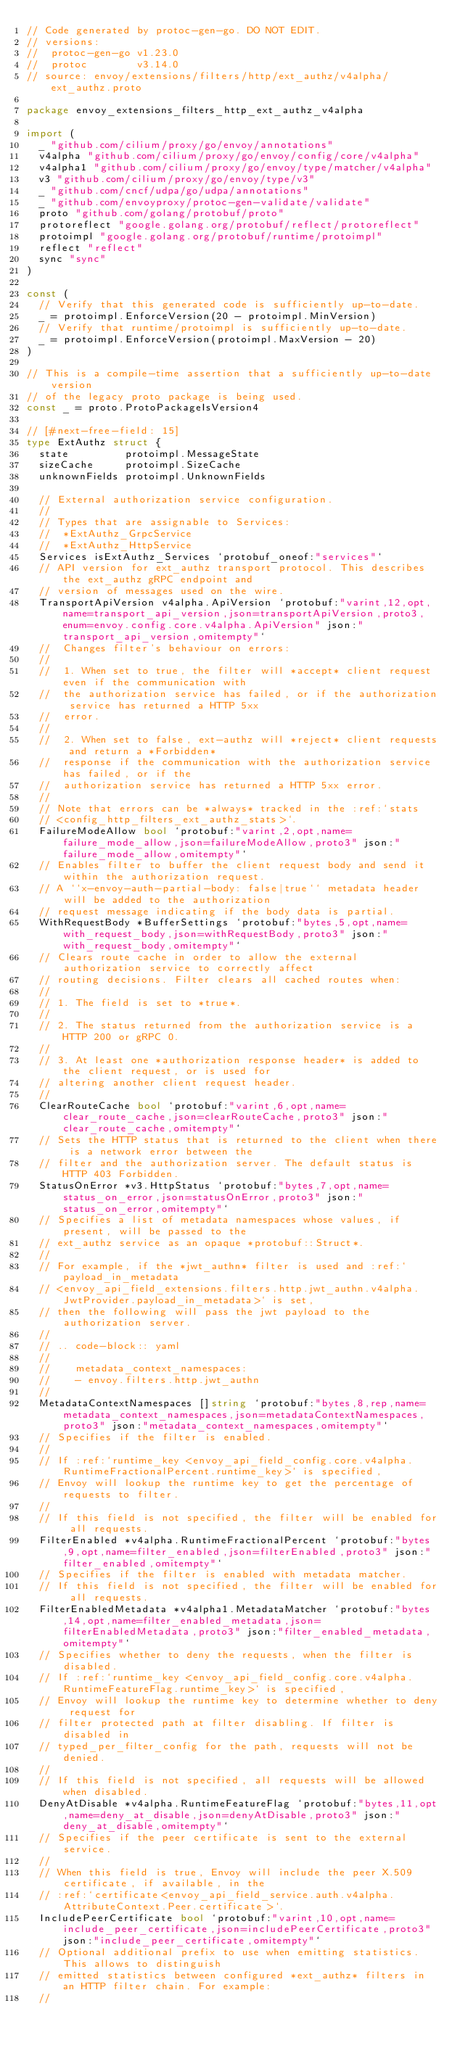<code> <loc_0><loc_0><loc_500><loc_500><_Go_>// Code generated by protoc-gen-go. DO NOT EDIT.
// versions:
// 	protoc-gen-go v1.23.0
// 	protoc        v3.14.0
// source: envoy/extensions/filters/http/ext_authz/v4alpha/ext_authz.proto

package envoy_extensions_filters_http_ext_authz_v4alpha

import (
	_ "github.com/cilium/proxy/go/envoy/annotations"
	v4alpha "github.com/cilium/proxy/go/envoy/config/core/v4alpha"
	v4alpha1 "github.com/cilium/proxy/go/envoy/type/matcher/v4alpha"
	v3 "github.com/cilium/proxy/go/envoy/type/v3"
	_ "github.com/cncf/udpa/go/udpa/annotations"
	_ "github.com/envoyproxy/protoc-gen-validate/validate"
	proto "github.com/golang/protobuf/proto"
	protoreflect "google.golang.org/protobuf/reflect/protoreflect"
	protoimpl "google.golang.org/protobuf/runtime/protoimpl"
	reflect "reflect"
	sync "sync"
)

const (
	// Verify that this generated code is sufficiently up-to-date.
	_ = protoimpl.EnforceVersion(20 - protoimpl.MinVersion)
	// Verify that runtime/protoimpl is sufficiently up-to-date.
	_ = protoimpl.EnforceVersion(protoimpl.MaxVersion - 20)
)

// This is a compile-time assertion that a sufficiently up-to-date version
// of the legacy proto package is being used.
const _ = proto.ProtoPackageIsVersion4

// [#next-free-field: 15]
type ExtAuthz struct {
	state         protoimpl.MessageState
	sizeCache     protoimpl.SizeCache
	unknownFields protoimpl.UnknownFields

	// External authorization service configuration.
	//
	// Types that are assignable to Services:
	//	*ExtAuthz_GrpcService
	//	*ExtAuthz_HttpService
	Services isExtAuthz_Services `protobuf_oneof:"services"`
	// API version for ext_authz transport protocol. This describes the ext_authz gRPC endpoint and
	// version of messages used on the wire.
	TransportApiVersion v4alpha.ApiVersion `protobuf:"varint,12,opt,name=transport_api_version,json=transportApiVersion,proto3,enum=envoy.config.core.v4alpha.ApiVersion" json:"transport_api_version,omitempty"`
	//  Changes filter's behaviour on errors:
	//
	//  1. When set to true, the filter will *accept* client request even if the communication with
	//  the authorization service has failed, or if the authorization service has returned a HTTP 5xx
	//  error.
	//
	//  2. When set to false, ext-authz will *reject* client requests and return a *Forbidden*
	//  response if the communication with the authorization service has failed, or if the
	//  authorization service has returned a HTTP 5xx error.
	//
	// Note that errors can be *always* tracked in the :ref:`stats
	// <config_http_filters_ext_authz_stats>`.
	FailureModeAllow bool `protobuf:"varint,2,opt,name=failure_mode_allow,json=failureModeAllow,proto3" json:"failure_mode_allow,omitempty"`
	// Enables filter to buffer the client request body and send it within the authorization request.
	// A ``x-envoy-auth-partial-body: false|true`` metadata header will be added to the authorization
	// request message indicating if the body data is partial.
	WithRequestBody *BufferSettings `protobuf:"bytes,5,opt,name=with_request_body,json=withRequestBody,proto3" json:"with_request_body,omitempty"`
	// Clears route cache in order to allow the external authorization service to correctly affect
	// routing decisions. Filter clears all cached routes when:
	//
	// 1. The field is set to *true*.
	//
	// 2. The status returned from the authorization service is a HTTP 200 or gRPC 0.
	//
	// 3. At least one *authorization response header* is added to the client request, or is used for
	// altering another client request header.
	//
	ClearRouteCache bool `protobuf:"varint,6,opt,name=clear_route_cache,json=clearRouteCache,proto3" json:"clear_route_cache,omitempty"`
	// Sets the HTTP status that is returned to the client when there is a network error between the
	// filter and the authorization server. The default status is HTTP 403 Forbidden.
	StatusOnError *v3.HttpStatus `protobuf:"bytes,7,opt,name=status_on_error,json=statusOnError,proto3" json:"status_on_error,omitempty"`
	// Specifies a list of metadata namespaces whose values, if present, will be passed to the
	// ext_authz service as an opaque *protobuf::Struct*.
	//
	// For example, if the *jwt_authn* filter is used and :ref:`payload_in_metadata
	// <envoy_api_field_extensions.filters.http.jwt_authn.v4alpha.JwtProvider.payload_in_metadata>` is set,
	// then the following will pass the jwt payload to the authorization server.
	//
	// .. code-block:: yaml
	//
	//    metadata_context_namespaces:
	//    - envoy.filters.http.jwt_authn
	//
	MetadataContextNamespaces []string `protobuf:"bytes,8,rep,name=metadata_context_namespaces,json=metadataContextNamespaces,proto3" json:"metadata_context_namespaces,omitempty"`
	// Specifies if the filter is enabled.
	//
	// If :ref:`runtime_key <envoy_api_field_config.core.v4alpha.RuntimeFractionalPercent.runtime_key>` is specified,
	// Envoy will lookup the runtime key to get the percentage of requests to filter.
	//
	// If this field is not specified, the filter will be enabled for all requests.
	FilterEnabled *v4alpha.RuntimeFractionalPercent `protobuf:"bytes,9,opt,name=filter_enabled,json=filterEnabled,proto3" json:"filter_enabled,omitempty"`
	// Specifies if the filter is enabled with metadata matcher.
	// If this field is not specified, the filter will be enabled for all requests.
	FilterEnabledMetadata *v4alpha1.MetadataMatcher `protobuf:"bytes,14,opt,name=filter_enabled_metadata,json=filterEnabledMetadata,proto3" json:"filter_enabled_metadata,omitempty"`
	// Specifies whether to deny the requests, when the filter is disabled.
	// If :ref:`runtime_key <envoy_api_field_config.core.v4alpha.RuntimeFeatureFlag.runtime_key>` is specified,
	// Envoy will lookup the runtime key to determine whether to deny request for
	// filter protected path at filter disabling. If filter is disabled in
	// typed_per_filter_config for the path, requests will not be denied.
	//
	// If this field is not specified, all requests will be allowed when disabled.
	DenyAtDisable *v4alpha.RuntimeFeatureFlag `protobuf:"bytes,11,opt,name=deny_at_disable,json=denyAtDisable,proto3" json:"deny_at_disable,omitempty"`
	// Specifies if the peer certificate is sent to the external service.
	//
	// When this field is true, Envoy will include the peer X.509 certificate, if available, in the
	// :ref:`certificate<envoy_api_field_service.auth.v4alpha.AttributeContext.Peer.certificate>`.
	IncludePeerCertificate bool `protobuf:"varint,10,opt,name=include_peer_certificate,json=includePeerCertificate,proto3" json:"include_peer_certificate,omitempty"`
	// Optional additional prefix to use when emitting statistics. This allows to distinguish
	// emitted statistics between configured *ext_authz* filters in an HTTP filter chain. For example:
	//</code> 